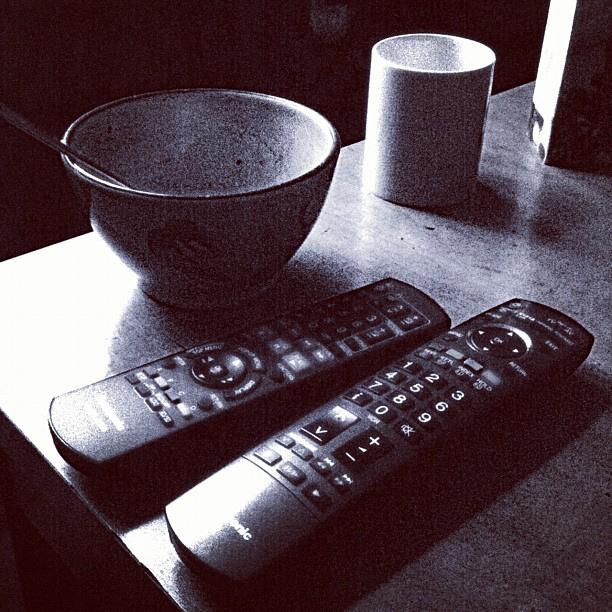How many electronic devices are on the table?
Keep it brief. 2. What is located on the table?
Give a very brief answer. Remotes. Is this picture in black and white?
Keep it brief. Yes. 